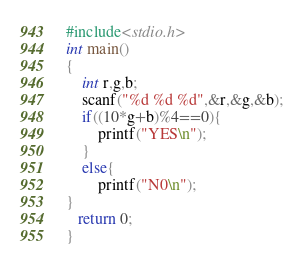<code> <loc_0><loc_0><loc_500><loc_500><_C_>#include<stdio.h>
int main()
{
    int r,g,b;
    scanf("%d %d %d",&r,&g,&b);
    if((10*g+b)%4==0){
        printf("YES\n");
    }
    else{
        printf("N0\n");
}
   return 0;
}</code> 